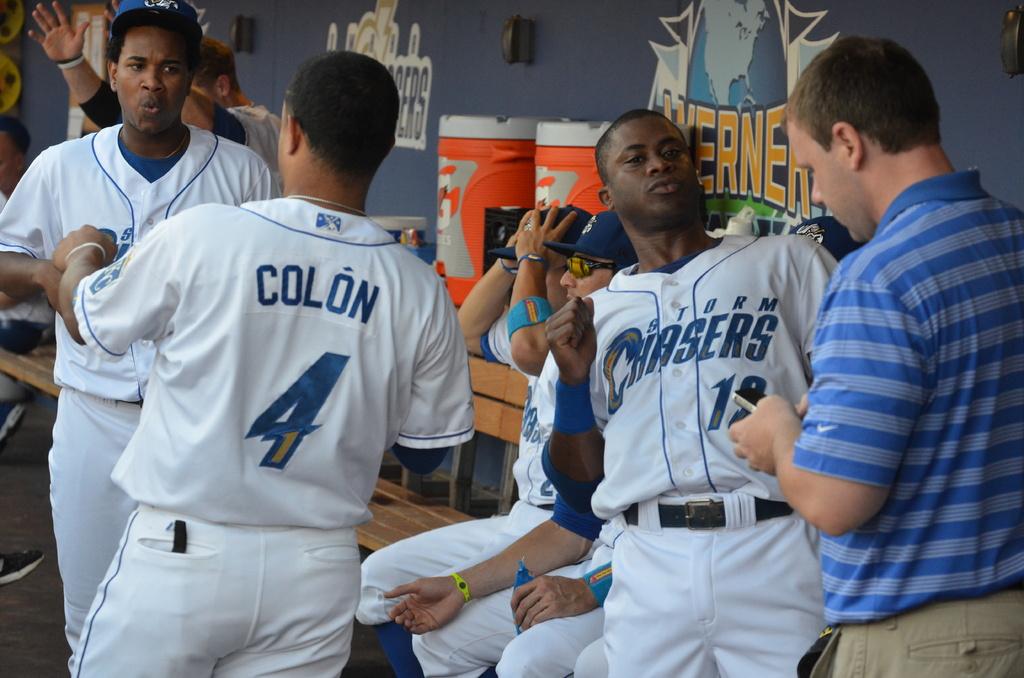What is the player's name?
Your answer should be compact. Colon. What is the player's number, with the last name colon?
Your response must be concise. 4. 